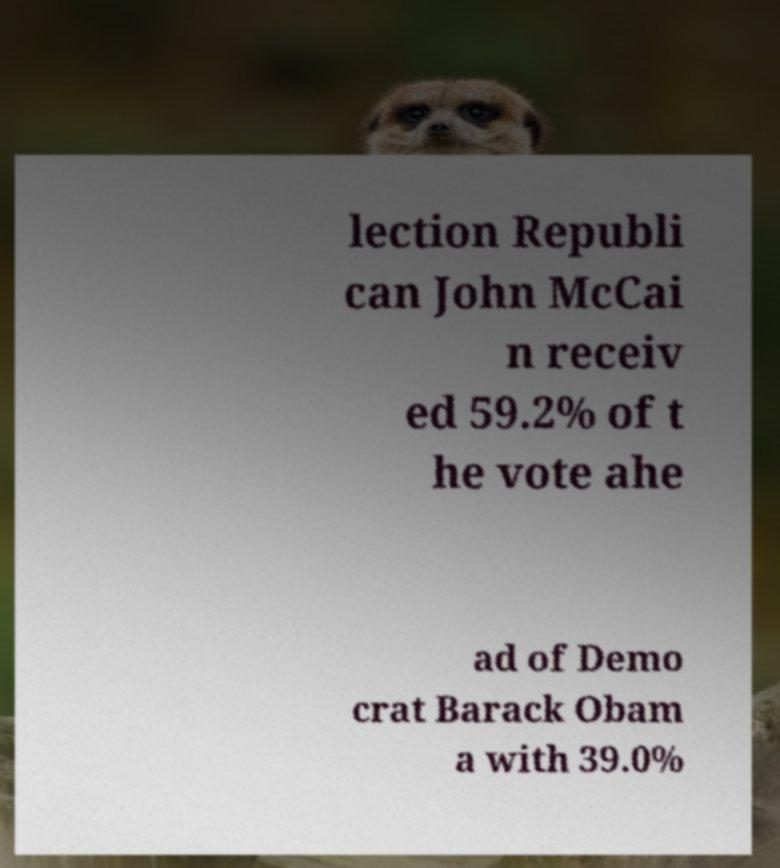What messages or text are displayed in this image? I need them in a readable, typed format. lection Republi can John McCai n receiv ed 59.2% of t he vote ahe ad of Demo crat Barack Obam a with 39.0% 